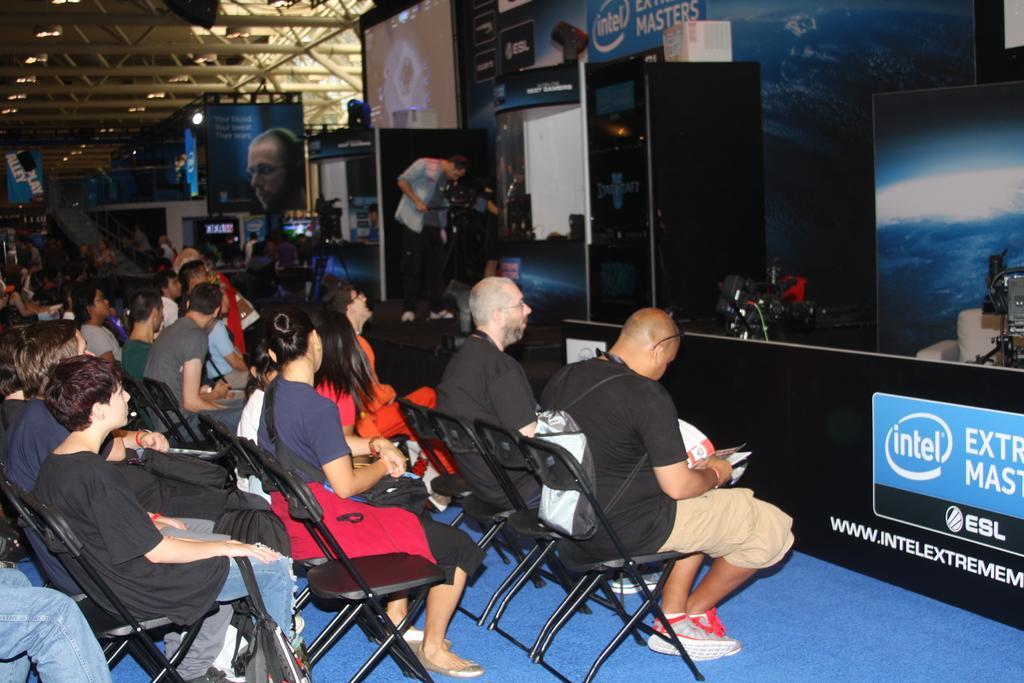How would you summarize this image in a sentence or two? In this picture there are group of people sitting on the chairs and there is a man standing and holding the camera and there are objects and there are boards and there is text on the boards. At the top there are lights. At the bottom there is a mat on the floor. On the right side of the image there is a chair and there are cameras. At the top there is a screen. 